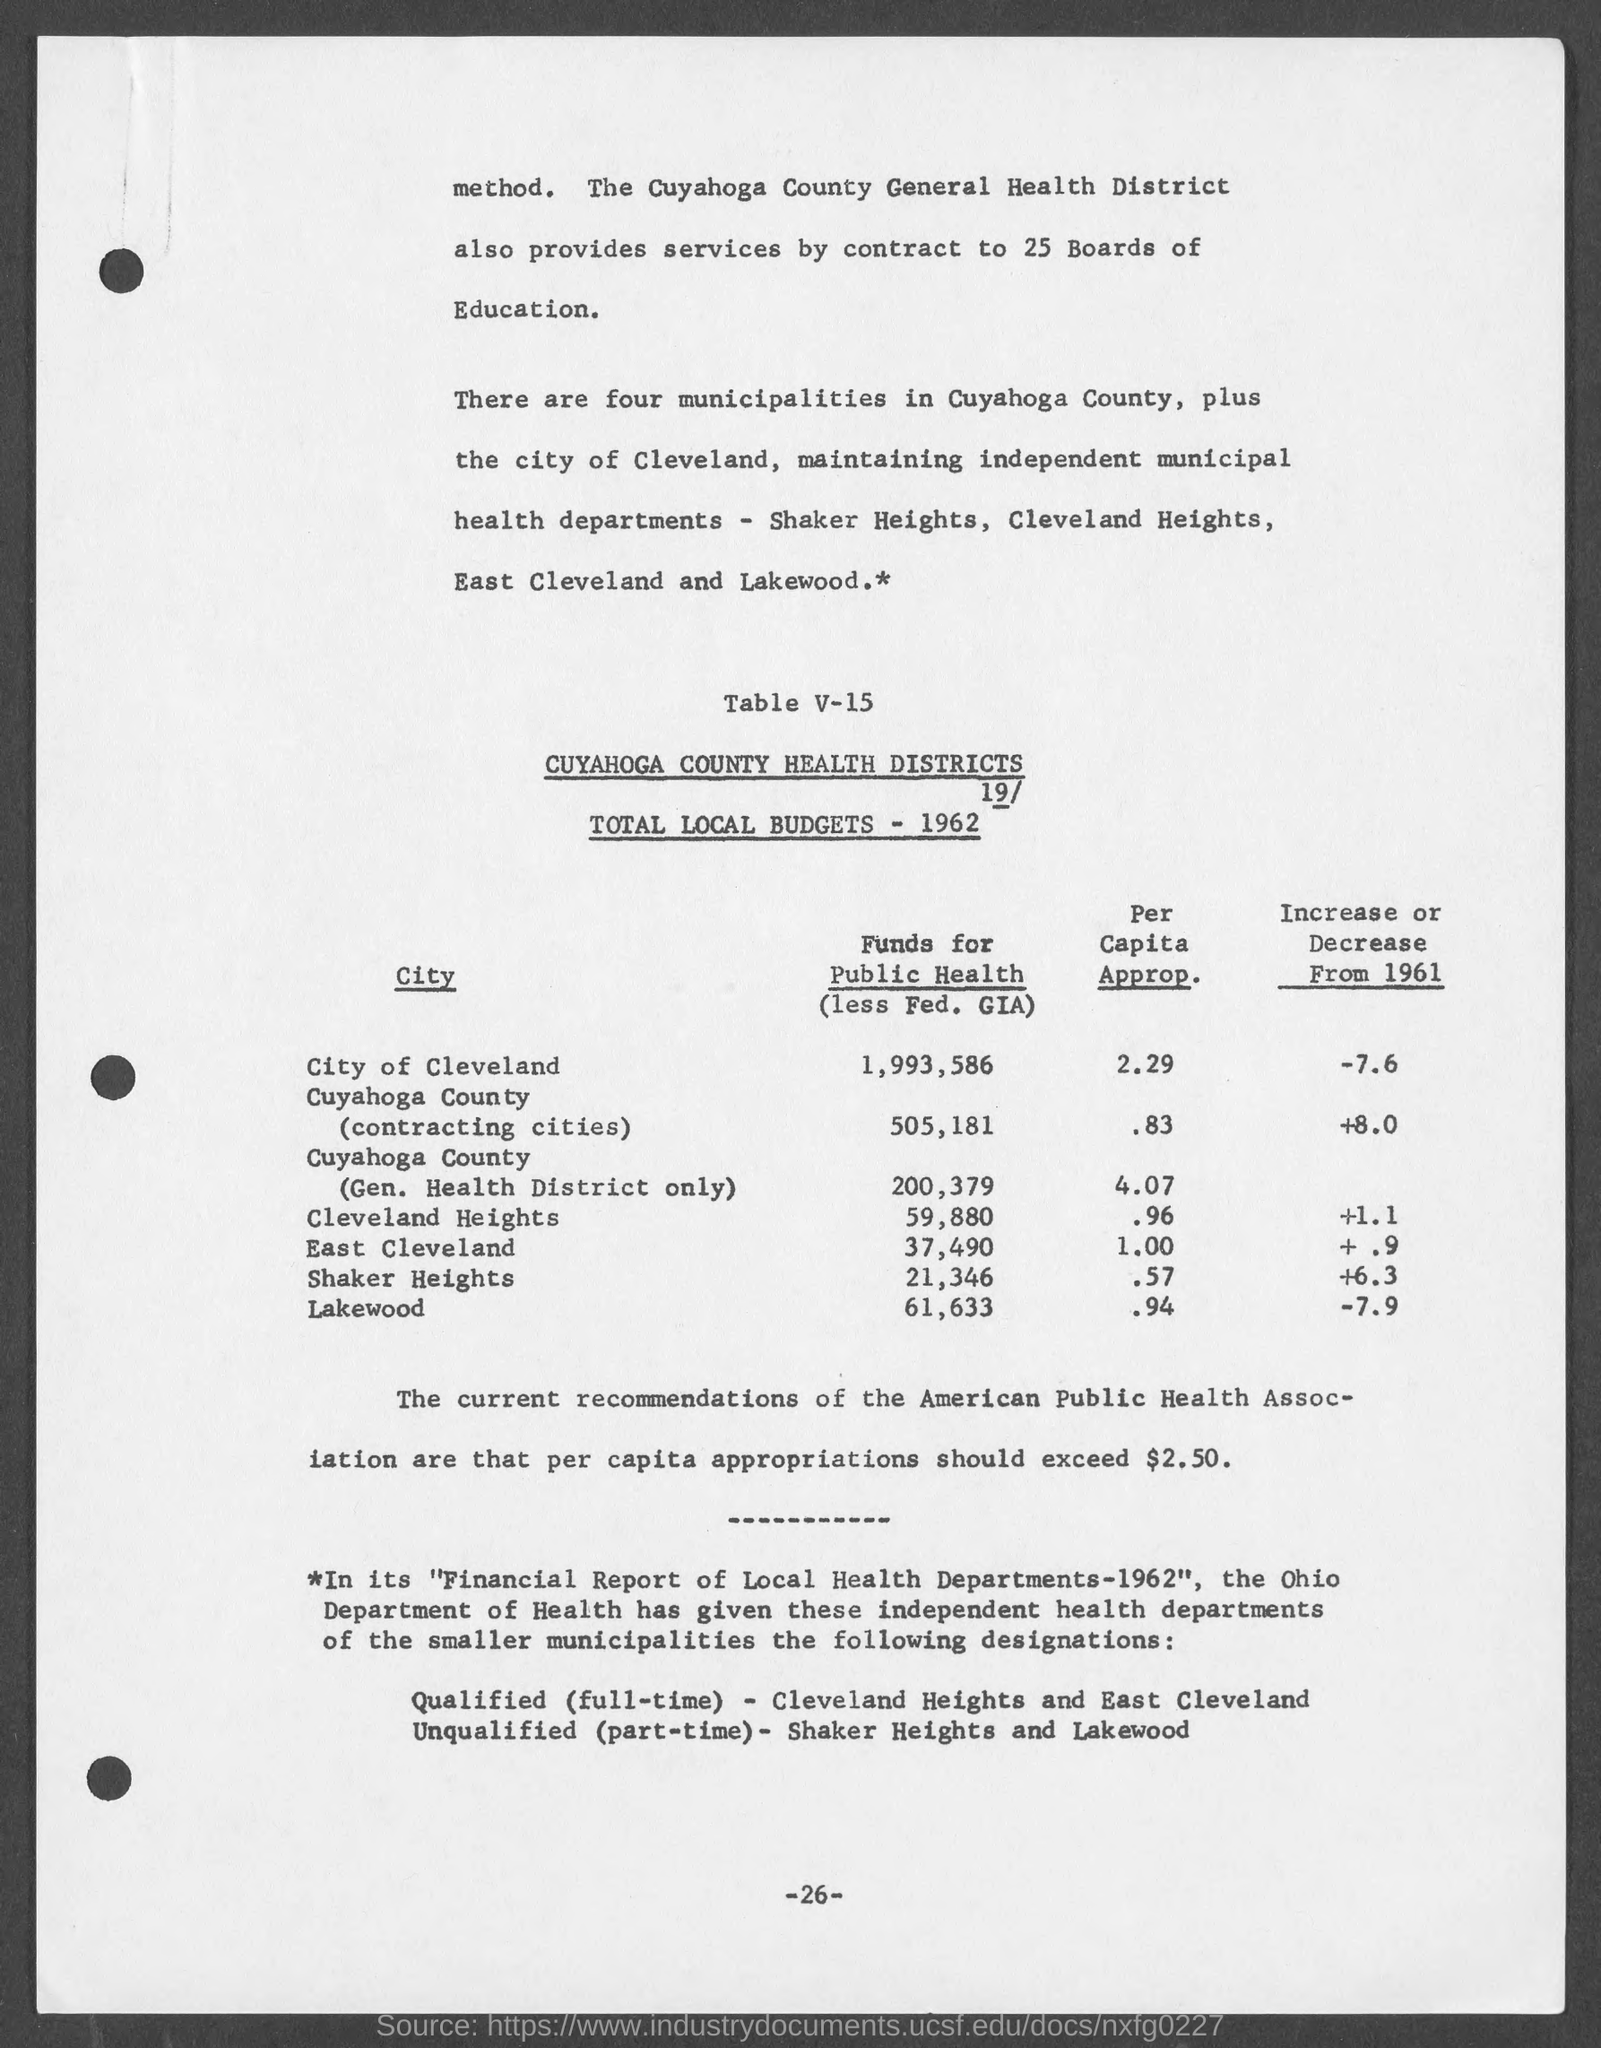How many municipalities in Cuyahoga County maintains independent health departments?
Make the answer very short. Four. 